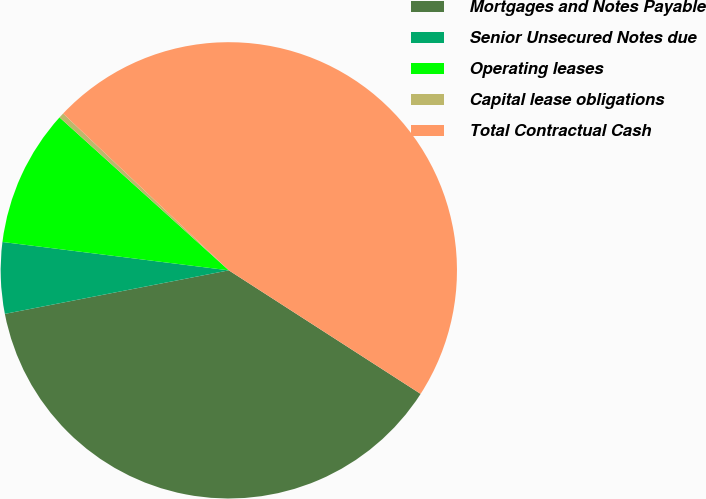Convert chart to OTSL. <chart><loc_0><loc_0><loc_500><loc_500><pie_chart><fcel>Mortgages and Notes Payable<fcel>Senior Unsecured Notes due<fcel>Operating leases<fcel>Capital lease obligations<fcel>Total Contractual Cash<nl><fcel>37.84%<fcel>5.04%<fcel>9.71%<fcel>0.37%<fcel>47.05%<nl></chart> 